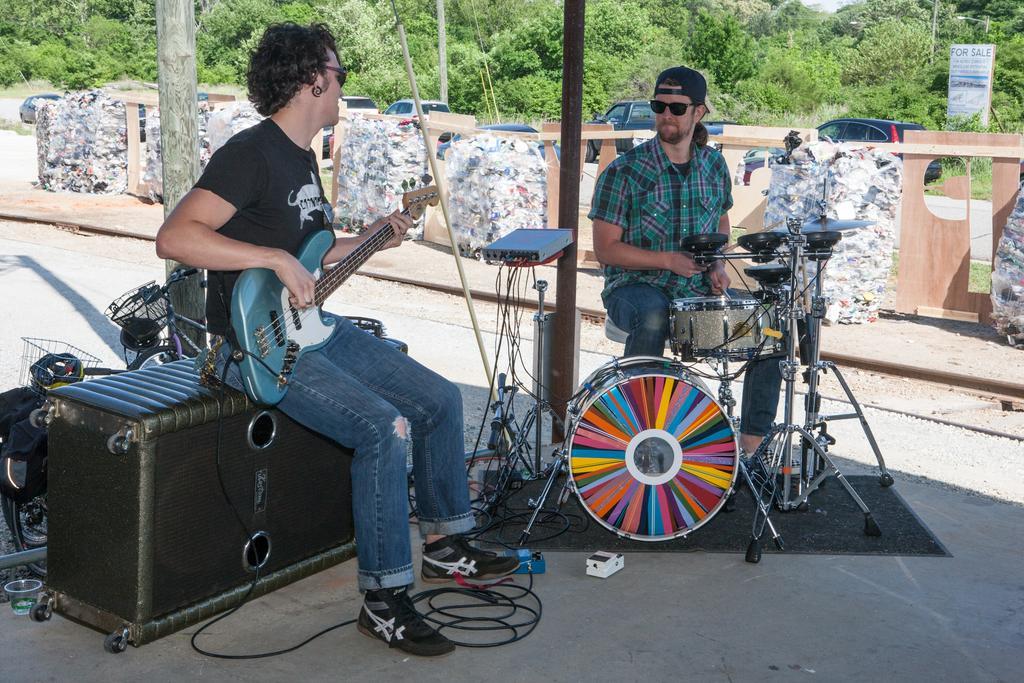In one or two sentences, can you explain what this image depicts? The person in the left is sitting on a speaker and playing guitar and the person in the right is playing drums, In background there are trees and cars behind them. 